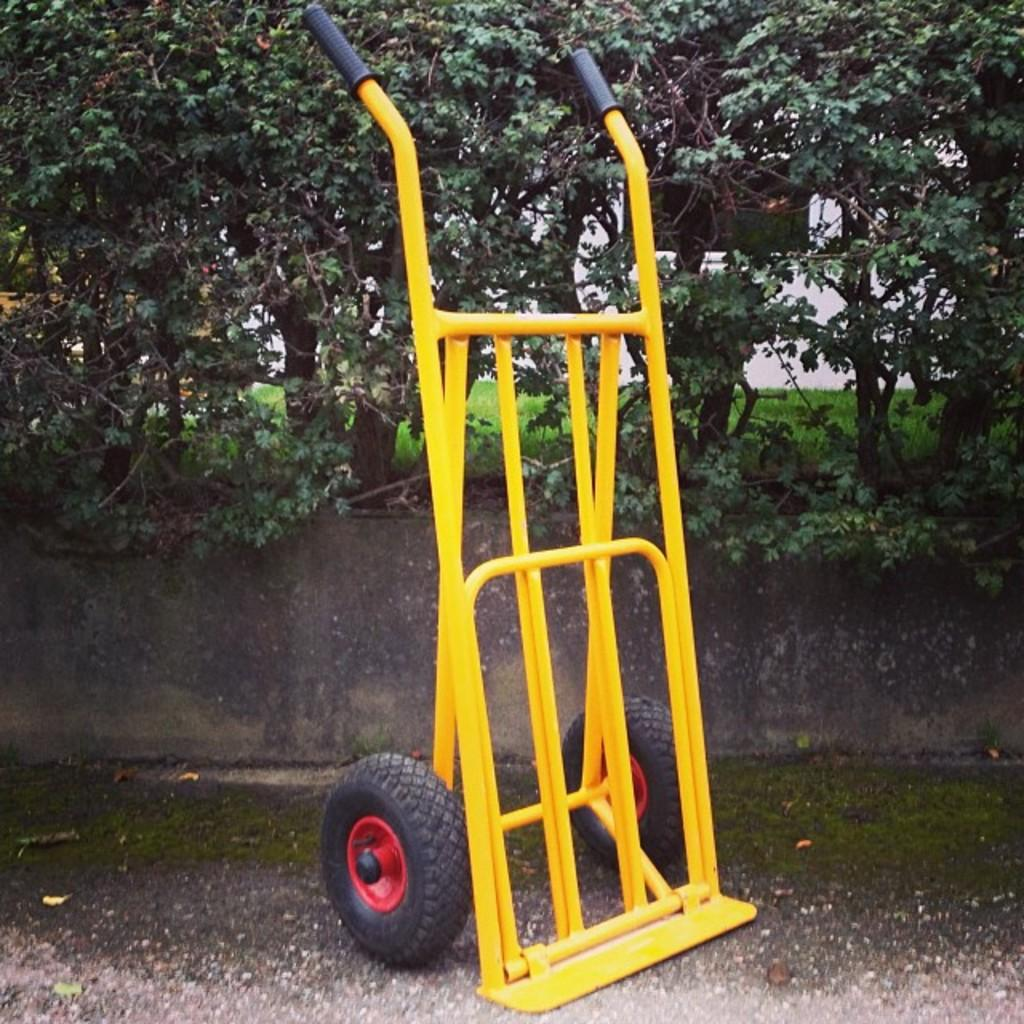What object is on the ground in the image? There is a cart on the ground in the image. What can be seen in the background of the image? There is a wall, trees, a field, and the sky visible in the background of the image. Where is the toothpaste located in the image? There is no toothpaste present in the image. What type of rabbit can be seen hopping in the field in the image? There is no rabbit present in the image; it only shows a cart on the ground and the background elements mentioned earlier. 